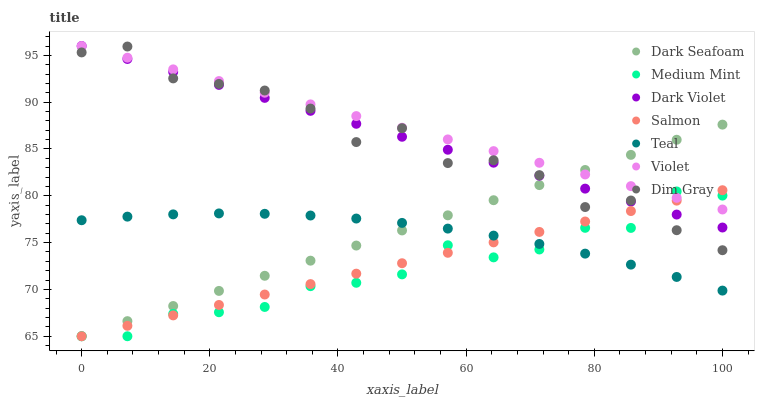Does Medium Mint have the minimum area under the curve?
Answer yes or no. Yes. Does Violet have the maximum area under the curve?
Answer yes or no. Yes. Does Dim Gray have the minimum area under the curve?
Answer yes or no. No. Does Dim Gray have the maximum area under the curve?
Answer yes or no. No. Is Dark Violet the smoothest?
Answer yes or no. Yes. Is Dim Gray the roughest?
Answer yes or no. Yes. Is Salmon the smoothest?
Answer yes or no. No. Is Salmon the roughest?
Answer yes or no. No. Does Medium Mint have the lowest value?
Answer yes or no. Yes. Does Dim Gray have the lowest value?
Answer yes or no. No. Does Violet have the highest value?
Answer yes or no. Yes. Does Dim Gray have the highest value?
Answer yes or no. No. Is Teal less than Dim Gray?
Answer yes or no. Yes. Is Violet greater than Teal?
Answer yes or no. Yes. Does Medium Mint intersect Dim Gray?
Answer yes or no. Yes. Is Medium Mint less than Dim Gray?
Answer yes or no. No. Is Medium Mint greater than Dim Gray?
Answer yes or no. No. Does Teal intersect Dim Gray?
Answer yes or no. No. 